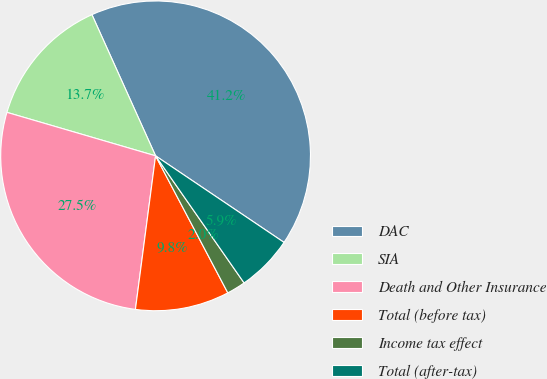Convert chart to OTSL. <chart><loc_0><loc_0><loc_500><loc_500><pie_chart><fcel>DAC<fcel>SIA<fcel>Death and Other Insurance<fcel>Total (before tax)<fcel>Income tax effect<fcel>Total (after-tax)<nl><fcel>41.18%<fcel>13.73%<fcel>27.45%<fcel>9.8%<fcel>1.96%<fcel>5.88%<nl></chart> 